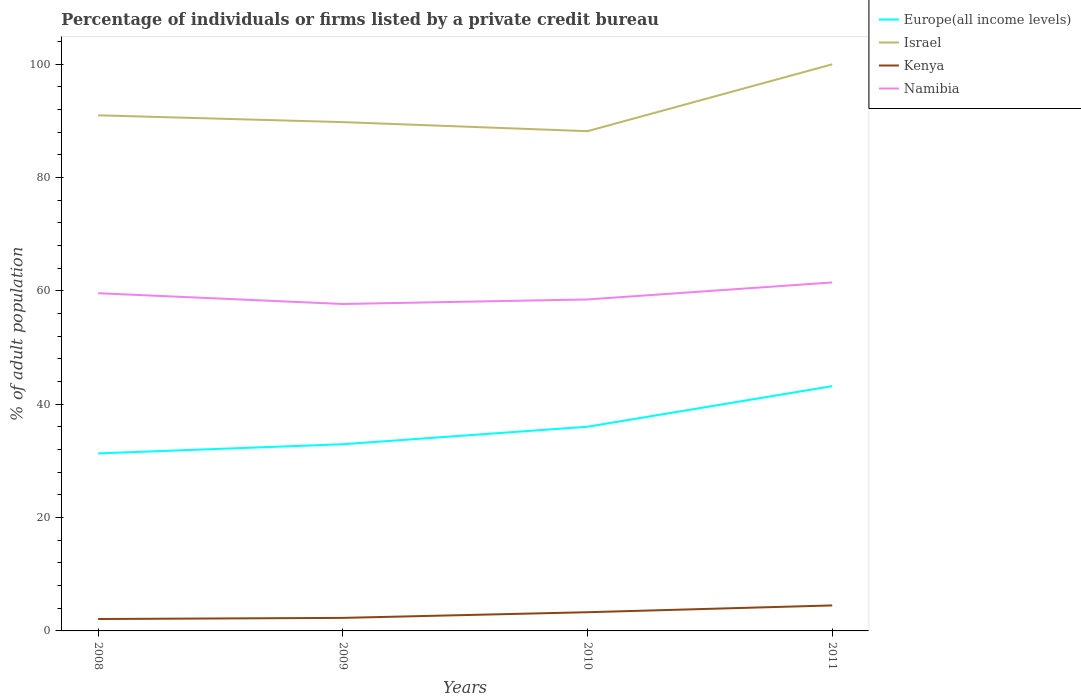Does the line corresponding to Europe(all income levels) intersect with the line corresponding to Namibia?
Provide a succinct answer. No. Is the number of lines equal to the number of legend labels?
Make the answer very short. Yes. What is the total percentage of population listed by a private credit bureau in Kenya in the graph?
Your answer should be compact. -1.2. What is the difference between the highest and the second highest percentage of population listed by a private credit bureau in Israel?
Provide a succinct answer. 11.8. Is the percentage of population listed by a private credit bureau in Israel strictly greater than the percentage of population listed by a private credit bureau in Kenya over the years?
Your answer should be very brief. No. How many years are there in the graph?
Offer a terse response. 4. Does the graph contain grids?
Your answer should be very brief. No. What is the title of the graph?
Offer a terse response. Percentage of individuals or firms listed by a private credit bureau. Does "Switzerland" appear as one of the legend labels in the graph?
Make the answer very short. No. What is the label or title of the X-axis?
Offer a terse response. Years. What is the label or title of the Y-axis?
Keep it short and to the point. % of adult population. What is the % of adult population of Europe(all income levels) in 2008?
Keep it short and to the point. 31.33. What is the % of adult population of Israel in 2008?
Provide a succinct answer. 91. What is the % of adult population in Namibia in 2008?
Your answer should be compact. 59.6. What is the % of adult population of Europe(all income levels) in 2009?
Offer a terse response. 32.95. What is the % of adult population of Israel in 2009?
Keep it short and to the point. 89.8. What is the % of adult population of Kenya in 2009?
Offer a terse response. 2.3. What is the % of adult population of Namibia in 2009?
Give a very brief answer. 57.7. What is the % of adult population of Europe(all income levels) in 2010?
Your answer should be very brief. 36.04. What is the % of adult population in Israel in 2010?
Offer a terse response. 88.2. What is the % of adult population of Namibia in 2010?
Your answer should be very brief. 58.5. What is the % of adult population of Europe(all income levels) in 2011?
Provide a short and direct response. 43.2. What is the % of adult population in Israel in 2011?
Your response must be concise. 100. What is the % of adult population of Namibia in 2011?
Provide a short and direct response. 61.5. Across all years, what is the maximum % of adult population in Europe(all income levels)?
Your answer should be compact. 43.2. Across all years, what is the maximum % of adult population of Kenya?
Make the answer very short. 4.5. Across all years, what is the maximum % of adult population in Namibia?
Give a very brief answer. 61.5. Across all years, what is the minimum % of adult population in Europe(all income levels)?
Offer a very short reply. 31.33. Across all years, what is the minimum % of adult population in Israel?
Your answer should be compact. 88.2. Across all years, what is the minimum % of adult population in Kenya?
Your answer should be compact. 2.1. Across all years, what is the minimum % of adult population in Namibia?
Ensure brevity in your answer.  57.7. What is the total % of adult population of Europe(all income levels) in the graph?
Give a very brief answer. 143.52. What is the total % of adult population of Israel in the graph?
Offer a terse response. 369. What is the total % of adult population of Kenya in the graph?
Give a very brief answer. 12.2. What is the total % of adult population of Namibia in the graph?
Make the answer very short. 237.3. What is the difference between the % of adult population in Europe(all income levels) in 2008 and that in 2009?
Offer a very short reply. -1.62. What is the difference between the % of adult population of Europe(all income levels) in 2008 and that in 2010?
Your answer should be compact. -4.71. What is the difference between the % of adult population in Israel in 2008 and that in 2010?
Keep it short and to the point. 2.8. What is the difference between the % of adult population in Namibia in 2008 and that in 2010?
Provide a short and direct response. 1.1. What is the difference between the % of adult population of Europe(all income levels) in 2008 and that in 2011?
Provide a short and direct response. -11.87. What is the difference between the % of adult population of Namibia in 2008 and that in 2011?
Keep it short and to the point. -1.9. What is the difference between the % of adult population in Europe(all income levels) in 2009 and that in 2010?
Your response must be concise. -3.09. What is the difference between the % of adult population of Israel in 2009 and that in 2010?
Your response must be concise. 1.6. What is the difference between the % of adult population of Namibia in 2009 and that in 2010?
Provide a short and direct response. -0.8. What is the difference between the % of adult population in Europe(all income levels) in 2009 and that in 2011?
Your answer should be compact. -10.26. What is the difference between the % of adult population of Europe(all income levels) in 2010 and that in 2011?
Your answer should be very brief. -7.16. What is the difference between the % of adult population of Israel in 2010 and that in 2011?
Provide a short and direct response. -11.8. What is the difference between the % of adult population of Kenya in 2010 and that in 2011?
Provide a succinct answer. -1.2. What is the difference between the % of adult population of Europe(all income levels) in 2008 and the % of adult population of Israel in 2009?
Your answer should be compact. -58.47. What is the difference between the % of adult population in Europe(all income levels) in 2008 and the % of adult population in Kenya in 2009?
Provide a short and direct response. 29.03. What is the difference between the % of adult population in Europe(all income levels) in 2008 and the % of adult population in Namibia in 2009?
Keep it short and to the point. -26.37. What is the difference between the % of adult population of Israel in 2008 and the % of adult population of Kenya in 2009?
Provide a succinct answer. 88.7. What is the difference between the % of adult population in Israel in 2008 and the % of adult population in Namibia in 2009?
Your answer should be compact. 33.3. What is the difference between the % of adult population of Kenya in 2008 and the % of adult population of Namibia in 2009?
Provide a short and direct response. -55.6. What is the difference between the % of adult population of Europe(all income levels) in 2008 and the % of adult population of Israel in 2010?
Your answer should be very brief. -56.87. What is the difference between the % of adult population of Europe(all income levels) in 2008 and the % of adult population of Kenya in 2010?
Your response must be concise. 28.03. What is the difference between the % of adult population in Europe(all income levels) in 2008 and the % of adult population in Namibia in 2010?
Your response must be concise. -27.17. What is the difference between the % of adult population in Israel in 2008 and the % of adult population in Kenya in 2010?
Keep it short and to the point. 87.7. What is the difference between the % of adult population in Israel in 2008 and the % of adult population in Namibia in 2010?
Provide a short and direct response. 32.5. What is the difference between the % of adult population of Kenya in 2008 and the % of adult population of Namibia in 2010?
Provide a succinct answer. -56.4. What is the difference between the % of adult population in Europe(all income levels) in 2008 and the % of adult population in Israel in 2011?
Offer a very short reply. -68.67. What is the difference between the % of adult population of Europe(all income levels) in 2008 and the % of adult population of Kenya in 2011?
Provide a succinct answer. 26.83. What is the difference between the % of adult population of Europe(all income levels) in 2008 and the % of adult population of Namibia in 2011?
Ensure brevity in your answer.  -30.17. What is the difference between the % of adult population of Israel in 2008 and the % of adult population of Kenya in 2011?
Give a very brief answer. 86.5. What is the difference between the % of adult population in Israel in 2008 and the % of adult population in Namibia in 2011?
Your response must be concise. 29.5. What is the difference between the % of adult population in Kenya in 2008 and the % of adult population in Namibia in 2011?
Make the answer very short. -59.4. What is the difference between the % of adult population of Europe(all income levels) in 2009 and the % of adult population of Israel in 2010?
Make the answer very short. -55.25. What is the difference between the % of adult population of Europe(all income levels) in 2009 and the % of adult population of Kenya in 2010?
Offer a terse response. 29.65. What is the difference between the % of adult population in Europe(all income levels) in 2009 and the % of adult population in Namibia in 2010?
Ensure brevity in your answer.  -25.55. What is the difference between the % of adult population in Israel in 2009 and the % of adult population in Kenya in 2010?
Give a very brief answer. 86.5. What is the difference between the % of adult population in Israel in 2009 and the % of adult population in Namibia in 2010?
Give a very brief answer. 31.3. What is the difference between the % of adult population of Kenya in 2009 and the % of adult population of Namibia in 2010?
Your answer should be compact. -56.2. What is the difference between the % of adult population of Europe(all income levels) in 2009 and the % of adult population of Israel in 2011?
Make the answer very short. -67.05. What is the difference between the % of adult population of Europe(all income levels) in 2009 and the % of adult population of Kenya in 2011?
Provide a short and direct response. 28.45. What is the difference between the % of adult population in Europe(all income levels) in 2009 and the % of adult population in Namibia in 2011?
Ensure brevity in your answer.  -28.55. What is the difference between the % of adult population in Israel in 2009 and the % of adult population in Kenya in 2011?
Your answer should be very brief. 85.3. What is the difference between the % of adult population in Israel in 2009 and the % of adult population in Namibia in 2011?
Offer a terse response. 28.3. What is the difference between the % of adult population of Kenya in 2009 and the % of adult population of Namibia in 2011?
Keep it short and to the point. -59.2. What is the difference between the % of adult population of Europe(all income levels) in 2010 and the % of adult population of Israel in 2011?
Your answer should be very brief. -63.96. What is the difference between the % of adult population in Europe(all income levels) in 2010 and the % of adult population in Kenya in 2011?
Your answer should be very brief. 31.54. What is the difference between the % of adult population of Europe(all income levels) in 2010 and the % of adult population of Namibia in 2011?
Your answer should be very brief. -25.46. What is the difference between the % of adult population of Israel in 2010 and the % of adult population of Kenya in 2011?
Offer a terse response. 83.7. What is the difference between the % of adult population in Israel in 2010 and the % of adult population in Namibia in 2011?
Give a very brief answer. 26.7. What is the difference between the % of adult population in Kenya in 2010 and the % of adult population in Namibia in 2011?
Your response must be concise. -58.2. What is the average % of adult population in Europe(all income levels) per year?
Provide a succinct answer. 35.88. What is the average % of adult population of Israel per year?
Your response must be concise. 92.25. What is the average % of adult population of Kenya per year?
Your response must be concise. 3.05. What is the average % of adult population of Namibia per year?
Offer a very short reply. 59.33. In the year 2008, what is the difference between the % of adult population in Europe(all income levels) and % of adult population in Israel?
Offer a very short reply. -59.67. In the year 2008, what is the difference between the % of adult population in Europe(all income levels) and % of adult population in Kenya?
Offer a very short reply. 29.23. In the year 2008, what is the difference between the % of adult population in Europe(all income levels) and % of adult population in Namibia?
Your answer should be compact. -28.27. In the year 2008, what is the difference between the % of adult population of Israel and % of adult population of Kenya?
Give a very brief answer. 88.9. In the year 2008, what is the difference between the % of adult population in Israel and % of adult population in Namibia?
Make the answer very short. 31.4. In the year 2008, what is the difference between the % of adult population of Kenya and % of adult population of Namibia?
Offer a very short reply. -57.5. In the year 2009, what is the difference between the % of adult population of Europe(all income levels) and % of adult population of Israel?
Make the answer very short. -56.85. In the year 2009, what is the difference between the % of adult population of Europe(all income levels) and % of adult population of Kenya?
Provide a short and direct response. 30.65. In the year 2009, what is the difference between the % of adult population in Europe(all income levels) and % of adult population in Namibia?
Your answer should be compact. -24.75. In the year 2009, what is the difference between the % of adult population in Israel and % of adult population in Kenya?
Your response must be concise. 87.5. In the year 2009, what is the difference between the % of adult population in Israel and % of adult population in Namibia?
Your answer should be very brief. 32.1. In the year 2009, what is the difference between the % of adult population of Kenya and % of adult population of Namibia?
Keep it short and to the point. -55.4. In the year 2010, what is the difference between the % of adult population of Europe(all income levels) and % of adult population of Israel?
Ensure brevity in your answer.  -52.16. In the year 2010, what is the difference between the % of adult population of Europe(all income levels) and % of adult population of Kenya?
Your answer should be compact. 32.74. In the year 2010, what is the difference between the % of adult population of Europe(all income levels) and % of adult population of Namibia?
Provide a short and direct response. -22.46. In the year 2010, what is the difference between the % of adult population in Israel and % of adult population in Kenya?
Your answer should be very brief. 84.9. In the year 2010, what is the difference between the % of adult population of Israel and % of adult population of Namibia?
Your response must be concise. 29.7. In the year 2010, what is the difference between the % of adult population of Kenya and % of adult population of Namibia?
Make the answer very short. -55.2. In the year 2011, what is the difference between the % of adult population in Europe(all income levels) and % of adult population in Israel?
Provide a succinct answer. -56.8. In the year 2011, what is the difference between the % of adult population in Europe(all income levels) and % of adult population in Kenya?
Your answer should be compact. 38.7. In the year 2011, what is the difference between the % of adult population of Europe(all income levels) and % of adult population of Namibia?
Offer a very short reply. -18.3. In the year 2011, what is the difference between the % of adult population of Israel and % of adult population of Kenya?
Keep it short and to the point. 95.5. In the year 2011, what is the difference between the % of adult population in Israel and % of adult population in Namibia?
Provide a succinct answer. 38.5. In the year 2011, what is the difference between the % of adult population in Kenya and % of adult population in Namibia?
Offer a very short reply. -57. What is the ratio of the % of adult population in Europe(all income levels) in 2008 to that in 2009?
Keep it short and to the point. 0.95. What is the ratio of the % of adult population of Israel in 2008 to that in 2009?
Your response must be concise. 1.01. What is the ratio of the % of adult population of Namibia in 2008 to that in 2009?
Ensure brevity in your answer.  1.03. What is the ratio of the % of adult population of Europe(all income levels) in 2008 to that in 2010?
Ensure brevity in your answer.  0.87. What is the ratio of the % of adult population of Israel in 2008 to that in 2010?
Your answer should be very brief. 1.03. What is the ratio of the % of adult population of Kenya in 2008 to that in 2010?
Your answer should be compact. 0.64. What is the ratio of the % of adult population in Namibia in 2008 to that in 2010?
Provide a succinct answer. 1.02. What is the ratio of the % of adult population of Europe(all income levels) in 2008 to that in 2011?
Offer a very short reply. 0.73. What is the ratio of the % of adult population in Israel in 2008 to that in 2011?
Your answer should be very brief. 0.91. What is the ratio of the % of adult population of Kenya in 2008 to that in 2011?
Your answer should be compact. 0.47. What is the ratio of the % of adult population in Namibia in 2008 to that in 2011?
Keep it short and to the point. 0.97. What is the ratio of the % of adult population in Europe(all income levels) in 2009 to that in 2010?
Provide a short and direct response. 0.91. What is the ratio of the % of adult population of Israel in 2009 to that in 2010?
Give a very brief answer. 1.02. What is the ratio of the % of adult population of Kenya in 2009 to that in 2010?
Give a very brief answer. 0.7. What is the ratio of the % of adult population of Namibia in 2009 to that in 2010?
Keep it short and to the point. 0.99. What is the ratio of the % of adult population of Europe(all income levels) in 2009 to that in 2011?
Ensure brevity in your answer.  0.76. What is the ratio of the % of adult population in Israel in 2009 to that in 2011?
Provide a succinct answer. 0.9. What is the ratio of the % of adult population in Kenya in 2009 to that in 2011?
Offer a very short reply. 0.51. What is the ratio of the % of adult population in Namibia in 2009 to that in 2011?
Give a very brief answer. 0.94. What is the ratio of the % of adult population in Europe(all income levels) in 2010 to that in 2011?
Offer a very short reply. 0.83. What is the ratio of the % of adult population in Israel in 2010 to that in 2011?
Provide a short and direct response. 0.88. What is the ratio of the % of adult population of Kenya in 2010 to that in 2011?
Your answer should be very brief. 0.73. What is the ratio of the % of adult population in Namibia in 2010 to that in 2011?
Provide a succinct answer. 0.95. What is the difference between the highest and the second highest % of adult population of Europe(all income levels)?
Your answer should be very brief. 7.16. What is the difference between the highest and the second highest % of adult population of Israel?
Offer a very short reply. 9. What is the difference between the highest and the second highest % of adult population of Kenya?
Offer a terse response. 1.2. What is the difference between the highest and the second highest % of adult population in Namibia?
Offer a very short reply. 1.9. What is the difference between the highest and the lowest % of adult population in Europe(all income levels)?
Offer a very short reply. 11.87. What is the difference between the highest and the lowest % of adult population of Israel?
Your response must be concise. 11.8. What is the difference between the highest and the lowest % of adult population of Namibia?
Offer a very short reply. 3.8. 